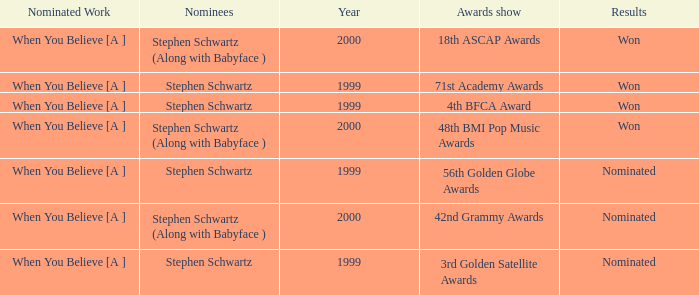What was the result in 2000? Won, Won, Nominated. 